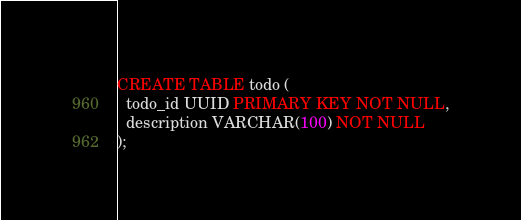Convert code to text. <code><loc_0><loc_0><loc_500><loc_500><_SQL_>
CREATE TABLE todo (
  todo_id UUID PRIMARY KEY NOT NULL,
  description VARCHAR(100) NOT NULL
); </code> 